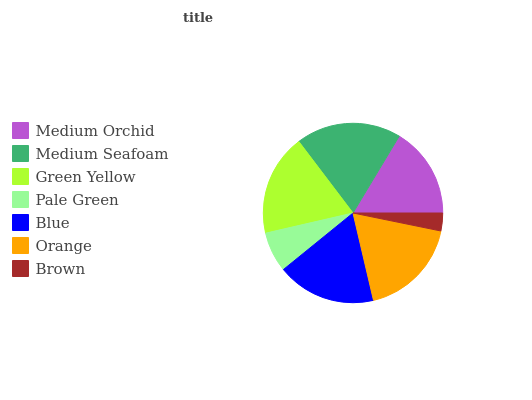Is Brown the minimum?
Answer yes or no. Yes. Is Medium Seafoam the maximum?
Answer yes or no. Yes. Is Green Yellow the minimum?
Answer yes or no. No. Is Green Yellow the maximum?
Answer yes or no. No. Is Medium Seafoam greater than Green Yellow?
Answer yes or no. Yes. Is Green Yellow less than Medium Seafoam?
Answer yes or no. Yes. Is Green Yellow greater than Medium Seafoam?
Answer yes or no. No. Is Medium Seafoam less than Green Yellow?
Answer yes or no. No. Is Blue the high median?
Answer yes or no. Yes. Is Blue the low median?
Answer yes or no. Yes. Is Medium Seafoam the high median?
Answer yes or no. No. Is Green Yellow the low median?
Answer yes or no. No. 